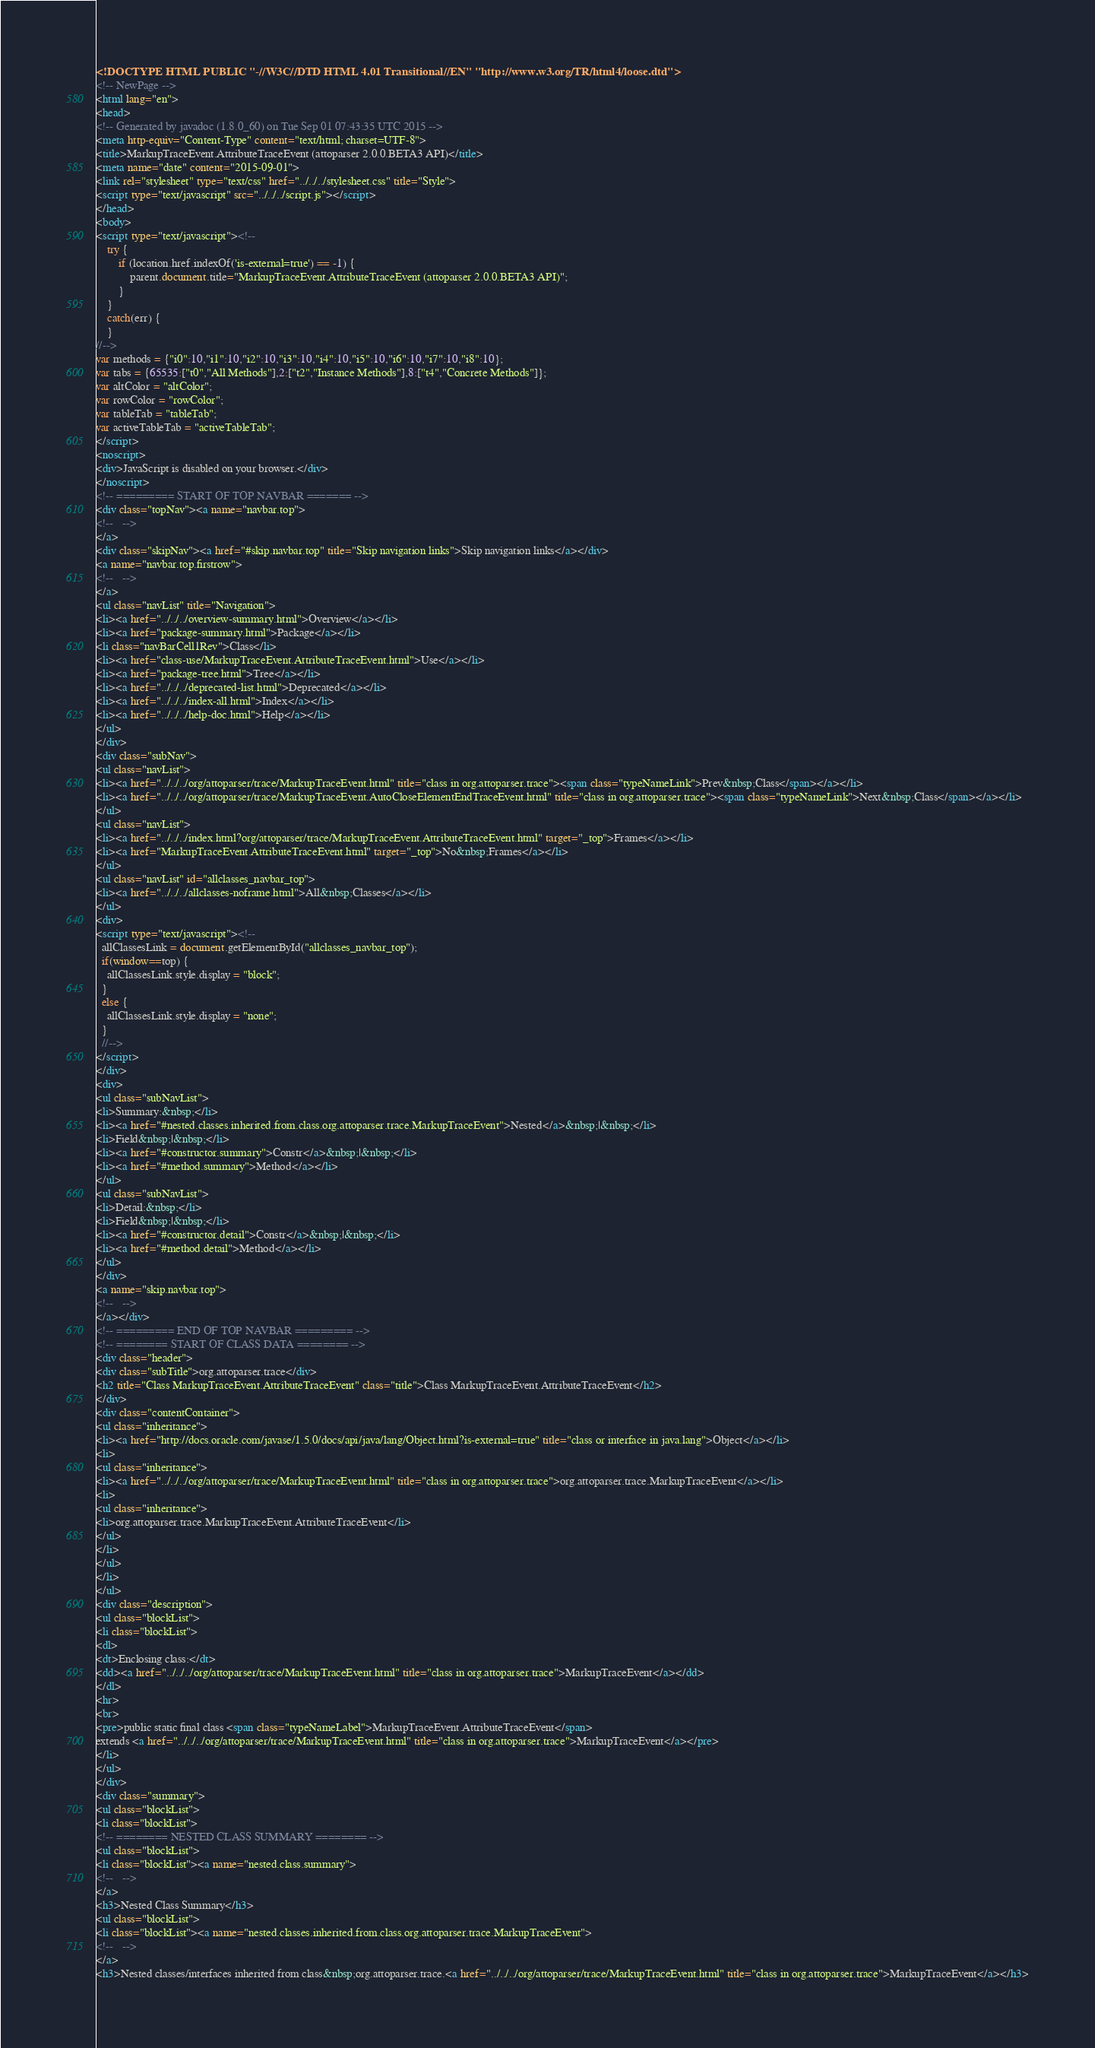Convert code to text. <code><loc_0><loc_0><loc_500><loc_500><_HTML_><!DOCTYPE HTML PUBLIC "-//W3C//DTD HTML 4.01 Transitional//EN" "http://www.w3.org/TR/html4/loose.dtd">
<!-- NewPage -->
<html lang="en">
<head>
<!-- Generated by javadoc (1.8.0_60) on Tue Sep 01 07:43:35 UTC 2015 -->
<meta http-equiv="Content-Type" content="text/html; charset=UTF-8">
<title>MarkupTraceEvent.AttributeTraceEvent (attoparser 2.0.0.BETA3 API)</title>
<meta name="date" content="2015-09-01">
<link rel="stylesheet" type="text/css" href="../../../stylesheet.css" title="Style">
<script type="text/javascript" src="../../../script.js"></script>
</head>
<body>
<script type="text/javascript"><!--
    try {
        if (location.href.indexOf('is-external=true') == -1) {
            parent.document.title="MarkupTraceEvent.AttributeTraceEvent (attoparser 2.0.0.BETA3 API)";
        }
    }
    catch(err) {
    }
//-->
var methods = {"i0":10,"i1":10,"i2":10,"i3":10,"i4":10,"i5":10,"i6":10,"i7":10,"i8":10};
var tabs = {65535:["t0","All Methods"],2:["t2","Instance Methods"],8:["t4","Concrete Methods"]};
var altColor = "altColor";
var rowColor = "rowColor";
var tableTab = "tableTab";
var activeTableTab = "activeTableTab";
</script>
<noscript>
<div>JavaScript is disabled on your browser.</div>
</noscript>
<!-- ========= START OF TOP NAVBAR ======= -->
<div class="topNav"><a name="navbar.top">
<!--   -->
</a>
<div class="skipNav"><a href="#skip.navbar.top" title="Skip navigation links">Skip navigation links</a></div>
<a name="navbar.top.firstrow">
<!--   -->
</a>
<ul class="navList" title="Navigation">
<li><a href="../../../overview-summary.html">Overview</a></li>
<li><a href="package-summary.html">Package</a></li>
<li class="navBarCell1Rev">Class</li>
<li><a href="class-use/MarkupTraceEvent.AttributeTraceEvent.html">Use</a></li>
<li><a href="package-tree.html">Tree</a></li>
<li><a href="../../../deprecated-list.html">Deprecated</a></li>
<li><a href="../../../index-all.html">Index</a></li>
<li><a href="../../../help-doc.html">Help</a></li>
</ul>
</div>
<div class="subNav">
<ul class="navList">
<li><a href="../../../org/attoparser/trace/MarkupTraceEvent.html" title="class in org.attoparser.trace"><span class="typeNameLink">Prev&nbsp;Class</span></a></li>
<li><a href="../../../org/attoparser/trace/MarkupTraceEvent.AutoCloseElementEndTraceEvent.html" title="class in org.attoparser.trace"><span class="typeNameLink">Next&nbsp;Class</span></a></li>
</ul>
<ul class="navList">
<li><a href="../../../index.html?org/attoparser/trace/MarkupTraceEvent.AttributeTraceEvent.html" target="_top">Frames</a></li>
<li><a href="MarkupTraceEvent.AttributeTraceEvent.html" target="_top">No&nbsp;Frames</a></li>
</ul>
<ul class="navList" id="allclasses_navbar_top">
<li><a href="../../../allclasses-noframe.html">All&nbsp;Classes</a></li>
</ul>
<div>
<script type="text/javascript"><!--
  allClassesLink = document.getElementById("allclasses_navbar_top");
  if(window==top) {
    allClassesLink.style.display = "block";
  }
  else {
    allClassesLink.style.display = "none";
  }
  //-->
</script>
</div>
<div>
<ul class="subNavList">
<li>Summary:&nbsp;</li>
<li><a href="#nested.classes.inherited.from.class.org.attoparser.trace.MarkupTraceEvent">Nested</a>&nbsp;|&nbsp;</li>
<li>Field&nbsp;|&nbsp;</li>
<li><a href="#constructor.summary">Constr</a>&nbsp;|&nbsp;</li>
<li><a href="#method.summary">Method</a></li>
</ul>
<ul class="subNavList">
<li>Detail:&nbsp;</li>
<li>Field&nbsp;|&nbsp;</li>
<li><a href="#constructor.detail">Constr</a>&nbsp;|&nbsp;</li>
<li><a href="#method.detail">Method</a></li>
</ul>
</div>
<a name="skip.navbar.top">
<!--   -->
</a></div>
<!-- ========= END OF TOP NAVBAR ========= -->
<!-- ======== START OF CLASS DATA ======== -->
<div class="header">
<div class="subTitle">org.attoparser.trace</div>
<h2 title="Class MarkupTraceEvent.AttributeTraceEvent" class="title">Class MarkupTraceEvent.AttributeTraceEvent</h2>
</div>
<div class="contentContainer">
<ul class="inheritance">
<li><a href="http://docs.oracle.com/javase/1.5.0/docs/api/java/lang/Object.html?is-external=true" title="class or interface in java.lang">Object</a></li>
<li>
<ul class="inheritance">
<li><a href="../../../org/attoparser/trace/MarkupTraceEvent.html" title="class in org.attoparser.trace">org.attoparser.trace.MarkupTraceEvent</a></li>
<li>
<ul class="inheritance">
<li>org.attoparser.trace.MarkupTraceEvent.AttributeTraceEvent</li>
</ul>
</li>
</ul>
</li>
</ul>
<div class="description">
<ul class="blockList">
<li class="blockList">
<dl>
<dt>Enclosing class:</dt>
<dd><a href="../../../org/attoparser/trace/MarkupTraceEvent.html" title="class in org.attoparser.trace">MarkupTraceEvent</a></dd>
</dl>
<hr>
<br>
<pre>public static final class <span class="typeNameLabel">MarkupTraceEvent.AttributeTraceEvent</span>
extends <a href="../../../org/attoparser/trace/MarkupTraceEvent.html" title="class in org.attoparser.trace">MarkupTraceEvent</a></pre>
</li>
</ul>
</div>
<div class="summary">
<ul class="blockList">
<li class="blockList">
<!-- ======== NESTED CLASS SUMMARY ======== -->
<ul class="blockList">
<li class="blockList"><a name="nested.class.summary">
<!--   -->
</a>
<h3>Nested Class Summary</h3>
<ul class="blockList">
<li class="blockList"><a name="nested.classes.inherited.from.class.org.attoparser.trace.MarkupTraceEvent">
<!--   -->
</a>
<h3>Nested classes/interfaces inherited from class&nbsp;org.attoparser.trace.<a href="../../../org/attoparser/trace/MarkupTraceEvent.html" title="class in org.attoparser.trace">MarkupTraceEvent</a></h3></code> 